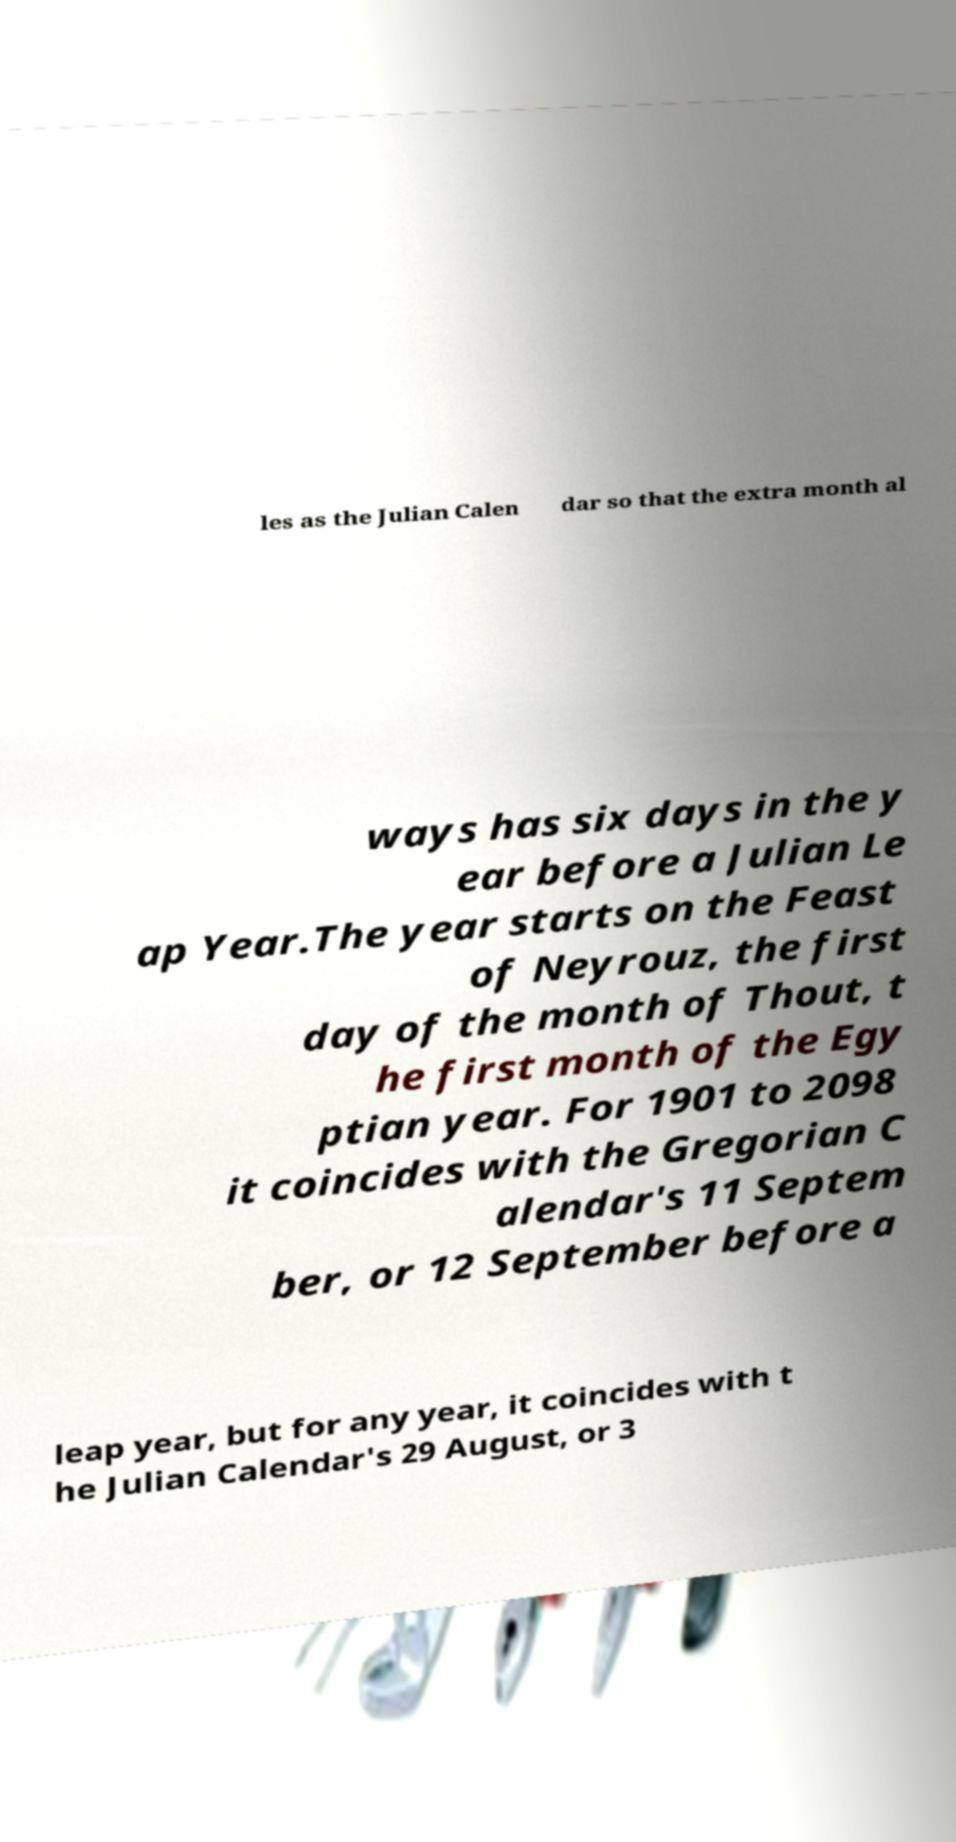What messages or text are displayed in this image? I need them in a readable, typed format. les as the Julian Calen dar so that the extra month al ways has six days in the y ear before a Julian Le ap Year.The year starts on the Feast of Neyrouz, the first day of the month of Thout, t he first month of the Egy ptian year. For 1901 to 2098 it coincides with the Gregorian C alendar's 11 Septem ber, or 12 September before a leap year, but for any year, it coincides with t he Julian Calendar's 29 August, or 3 